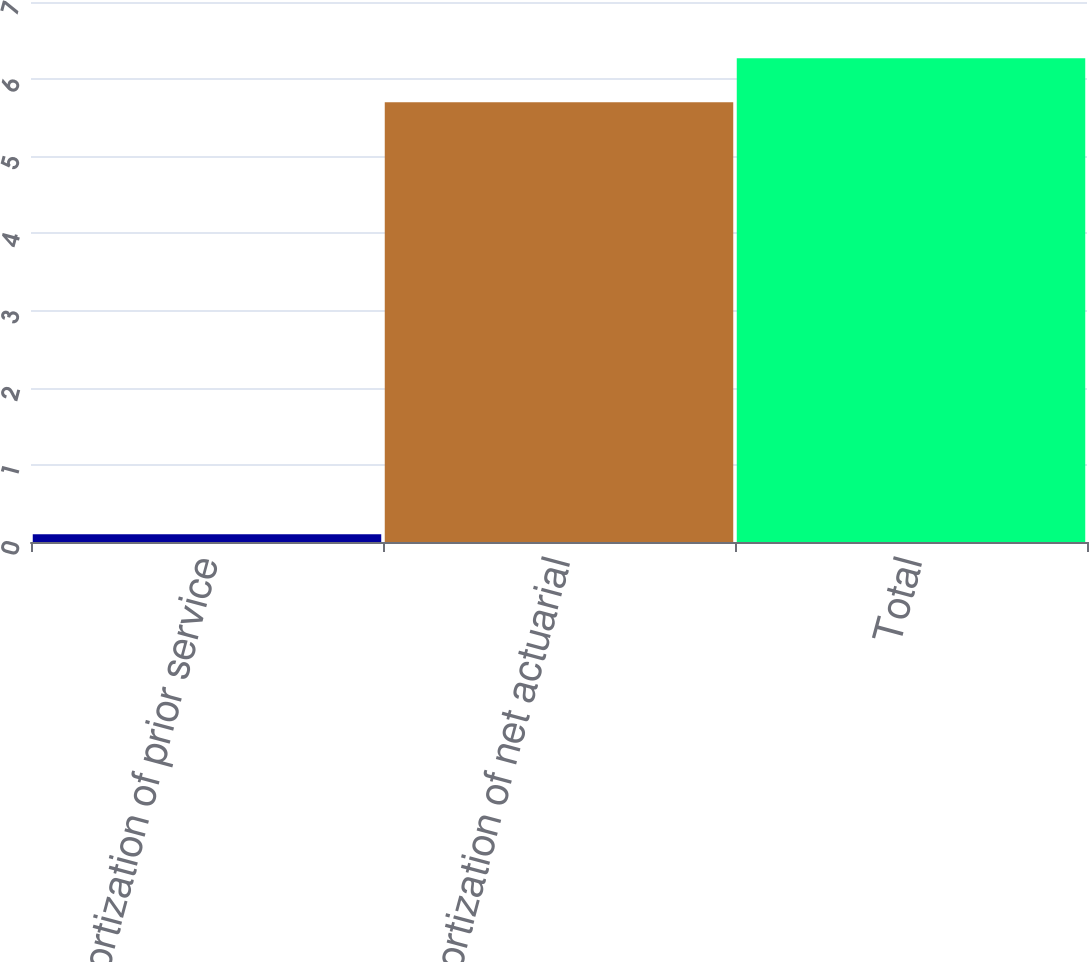<chart> <loc_0><loc_0><loc_500><loc_500><bar_chart><fcel>Amortization of prior service<fcel>Amortization of net actuarial<fcel>Total<nl><fcel>0.1<fcel>5.7<fcel>6.27<nl></chart> 